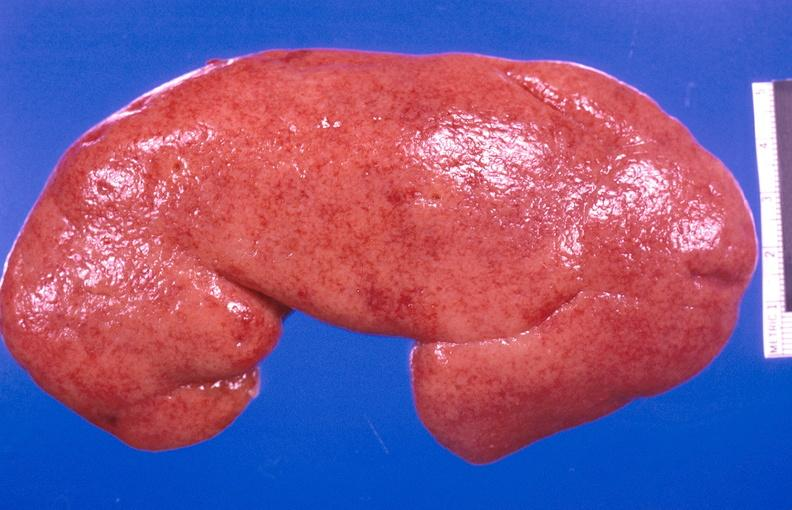where is this?
Answer the question using a single word or phrase. Urinary 